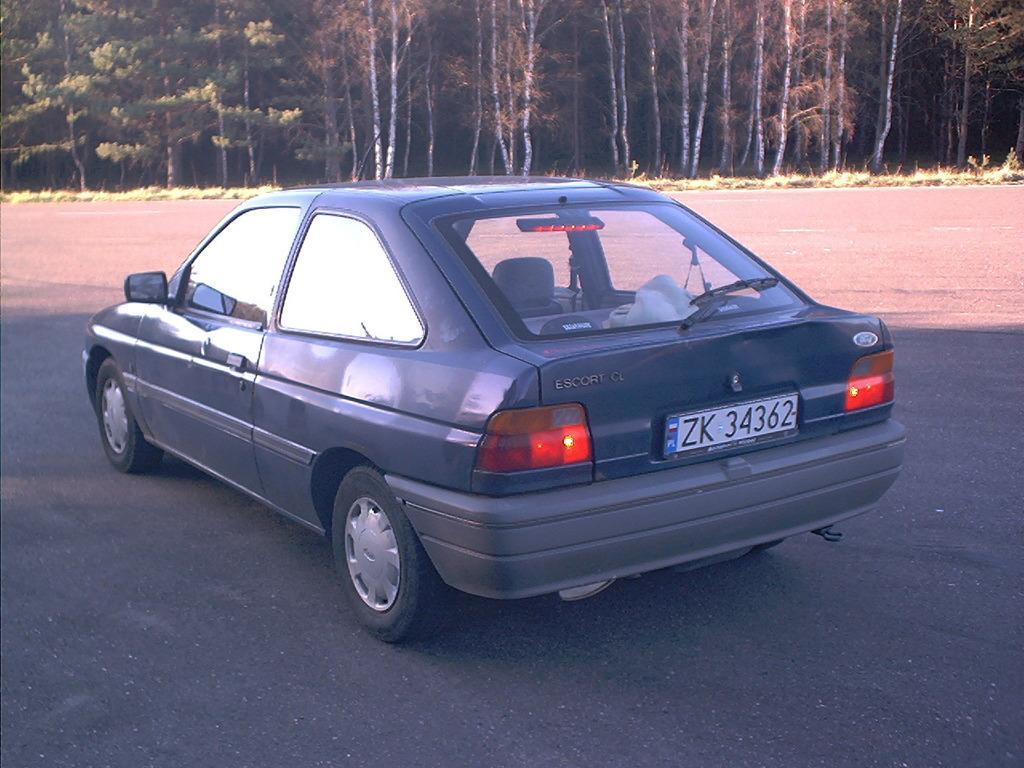How would you summarize this image in a sentence or two? In this picture we can see a car, in the background we can find few trees. 